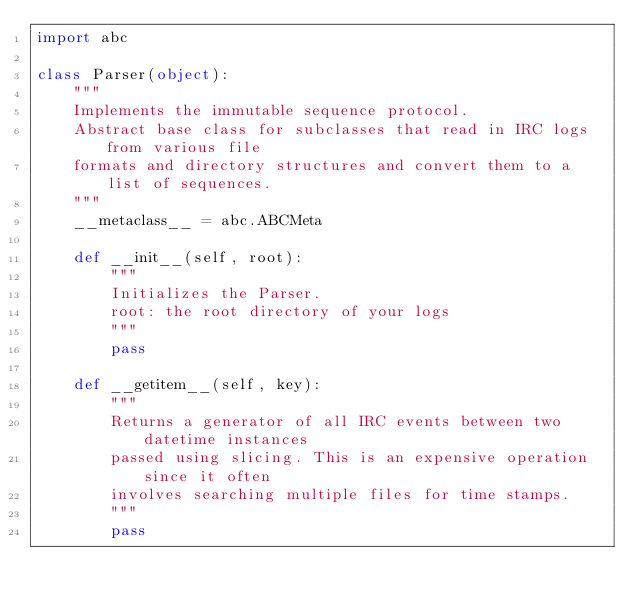<code> <loc_0><loc_0><loc_500><loc_500><_Python_>import abc

class Parser(object):
    """
    Implements the immutable sequence protocol.
    Abstract base class for subclasses that read in IRC logs from various file
    formats and directory structures and convert them to a list of sequences.
    """
    __metaclass__ = abc.ABCMeta

    def __init__(self, root):
        """
        Initializes the Parser.
        root: the root directory of your logs
        """
        pass

    def __getitem__(self, key):
        """
        Returns a generator of all IRC events between two datetime instances
        passed using slicing. This is an expensive operation since it often
        involves searching multiple files for time stamps.
        """
        pass
</code> 